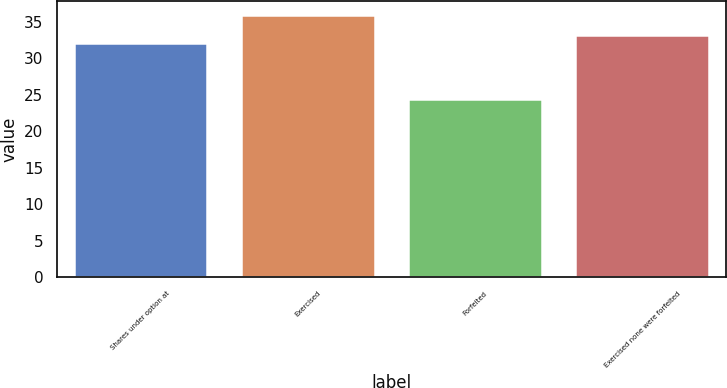Convert chart. <chart><loc_0><loc_0><loc_500><loc_500><bar_chart><fcel>Shares under option at<fcel>Exercised<fcel>Forfeited<fcel>Exercised none were forfeited<nl><fcel>32.07<fcel>36.02<fcel>24.47<fcel>33.23<nl></chart> 